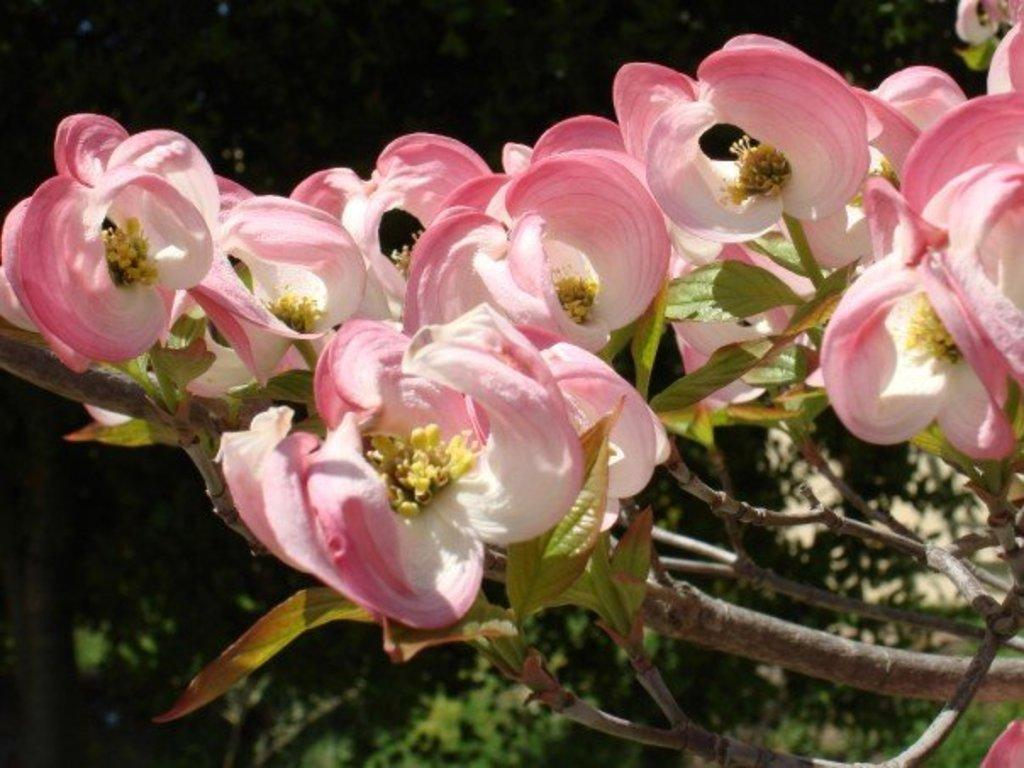What type of plants can be seen in the image? There are flowers in the image. How would you describe the overall lighting in the image? The background of the image is dark. What other natural elements are present in the image? There are trees in the image. What direction is the doll facing in the image? There is no doll present in the image. 